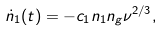Convert formula to latex. <formula><loc_0><loc_0><loc_500><loc_500>\dot { n } _ { 1 } ( t ) = - c _ { 1 } n _ { 1 } n _ { g } \nu ^ { 2 / 3 } ,</formula> 